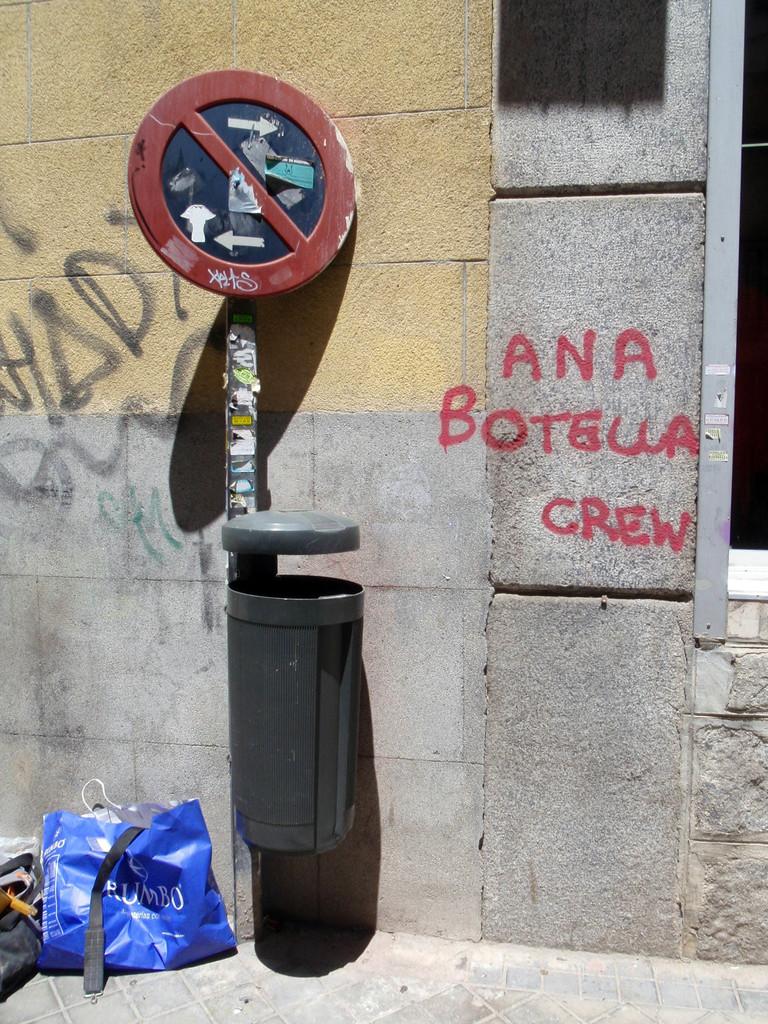What store is the blue bag from?
Make the answer very short. Rumbo. What kinda of crew mentioned is painted on the wall?
Provide a succinct answer. Ana botella. 